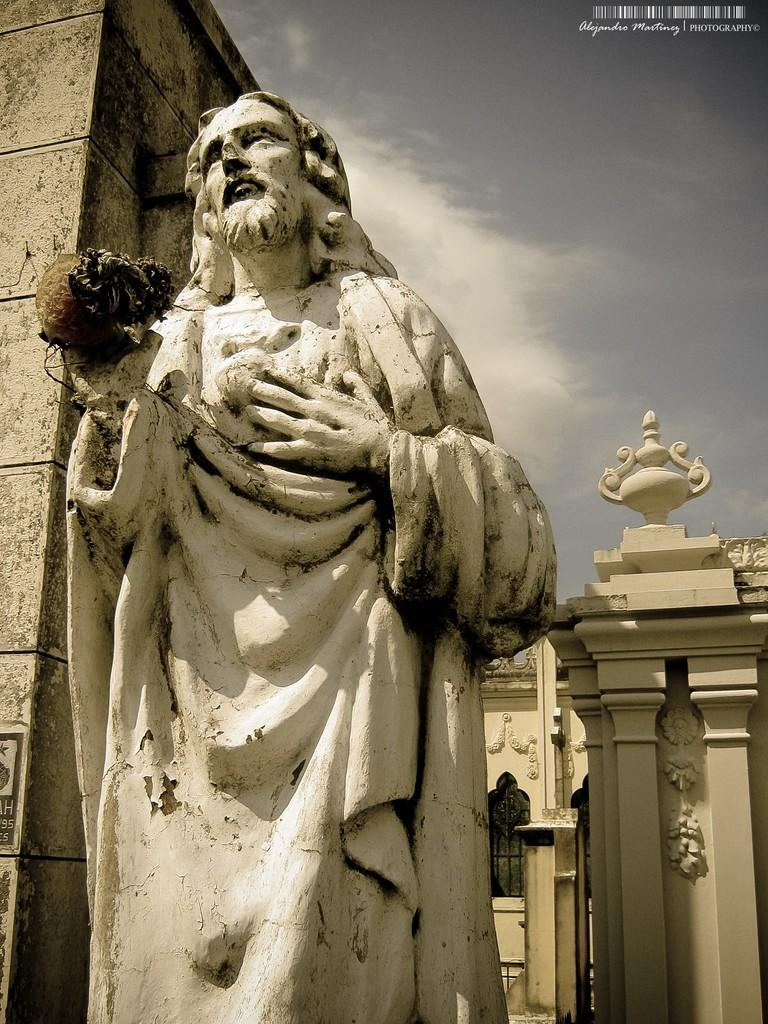What is the main subject in the image? There is a statue in the image. What can be seen behind the statue? There is a wall in the image. What is visible in the background of the image? There is a building in the background of the image. How would you describe the weather based on the image? The sky is cloudy in the image. What type of wine is being served in the jar next to the statue? There is no jar or wine present in the image; it only features a statue, a wall, a building in the background, and a cloudy sky. 